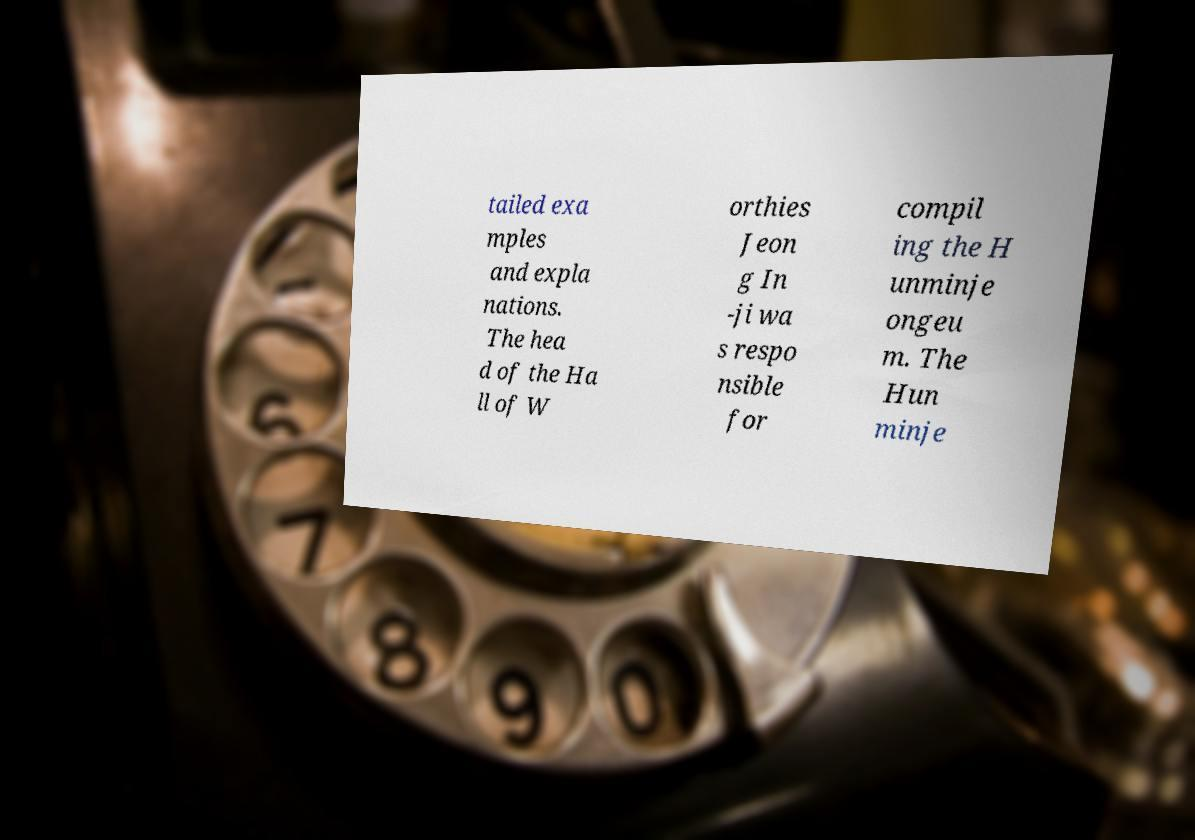Could you assist in decoding the text presented in this image and type it out clearly? tailed exa mples and expla nations. The hea d of the Ha ll of W orthies Jeon g In -ji wa s respo nsible for compil ing the H unminje ongeu m. The Hun minje 